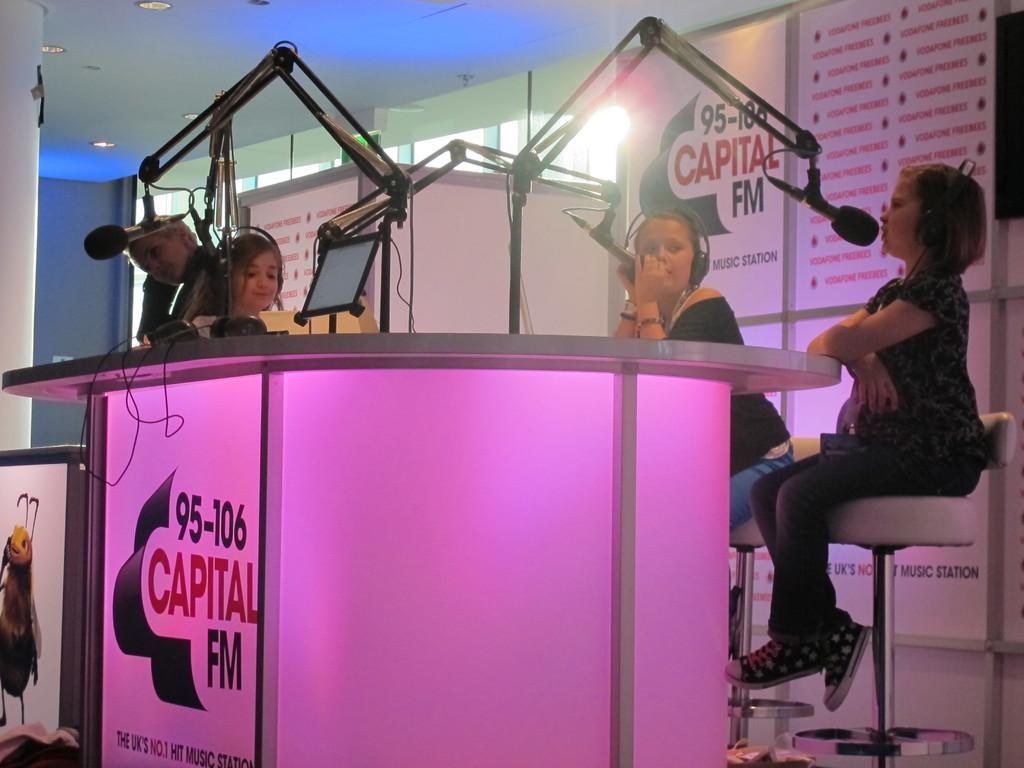Could you give a brief overview of what you see in this image? In this image there are 3 girls sitting in chair and talking in the microphones , and at the background there are hoardings, lights, table, screen. 